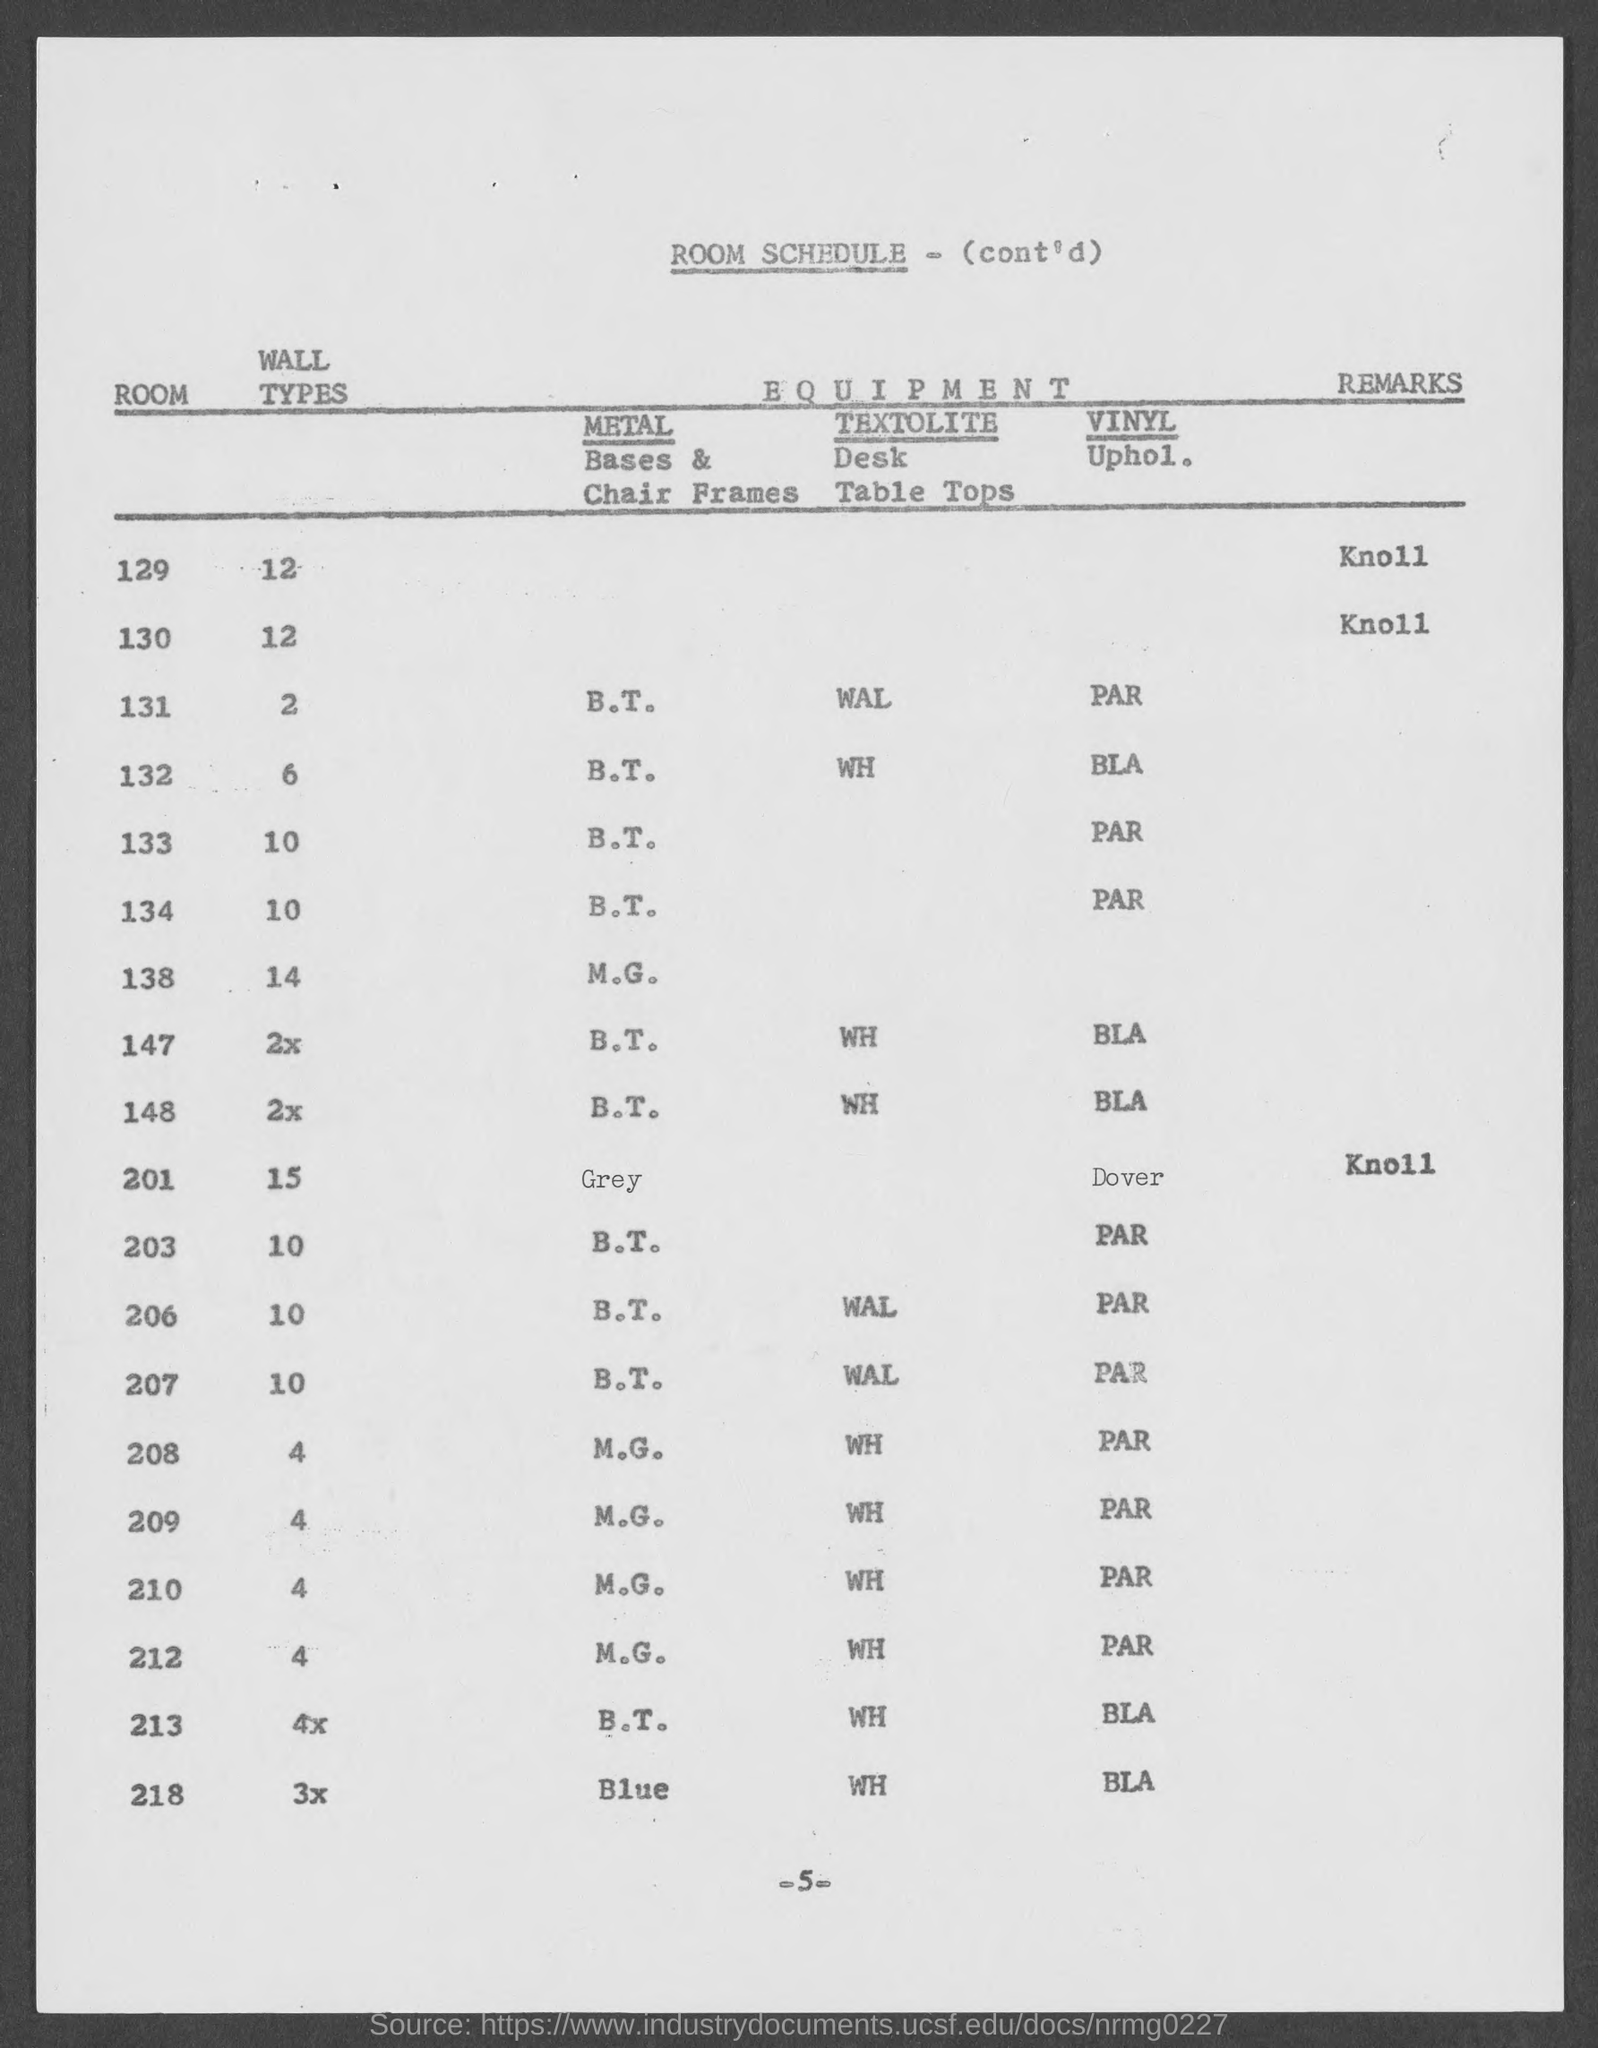What is the page number?
Ensure brevity in your answer.  - 5 -. What is the title of document?
Make the answer very short. Room schedule. What are the Wall Types in Room 129?
Provide a short and direct response. 12. What are the Wall Types in Room 130?
Offer a very short reply. 12. 